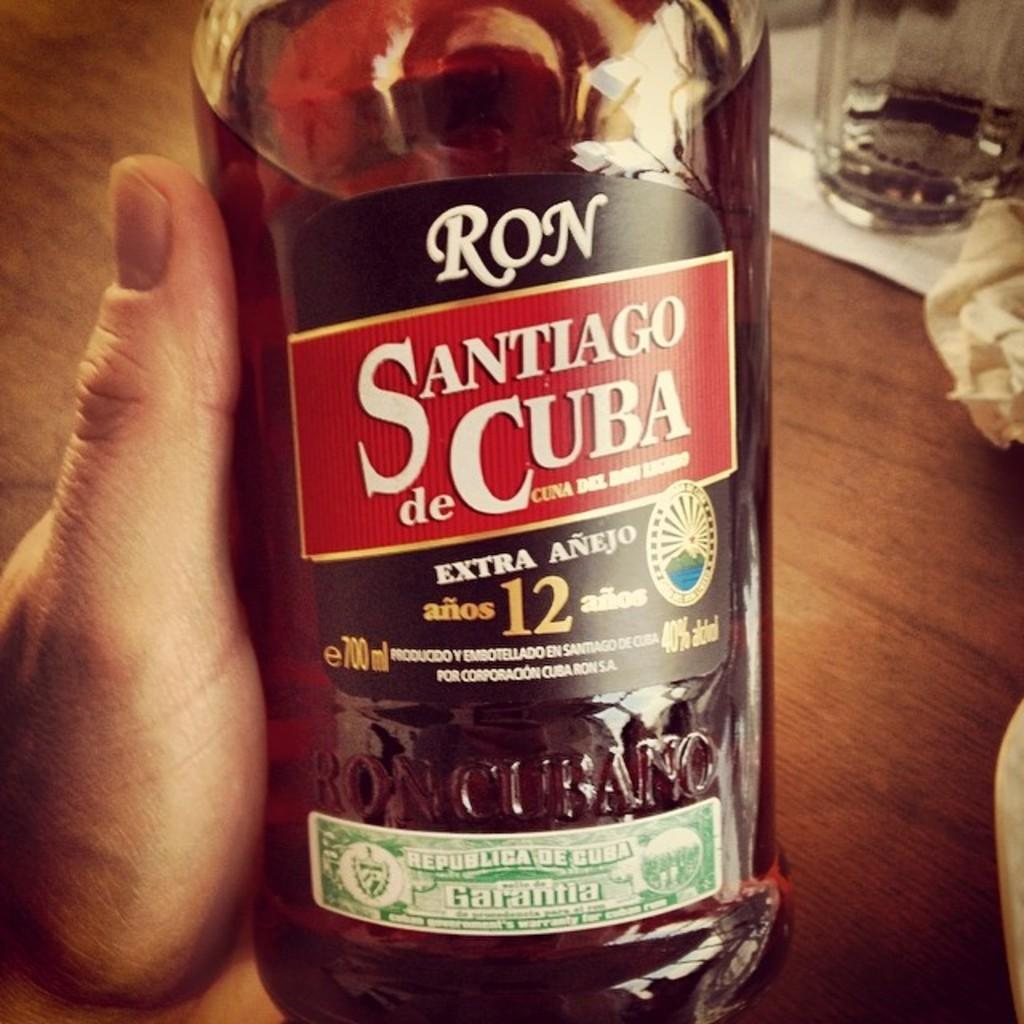What is being held by the person's hand in the image? There is a person's hand holding a bottle in the image. What can be observed on the bottle? The bottle has labels on it. What is inside the bottle? The bottle contains liquid. What type of surface is visible in the image? There is a wooden surface in the image. What else can be seen on the wooden surface? There are objects on the wooden surface. What type of lace can be seen on the calculator in the image? There is no calculator or lace present in the image. How is the rake being used in the image? There is no rake present in the image. 